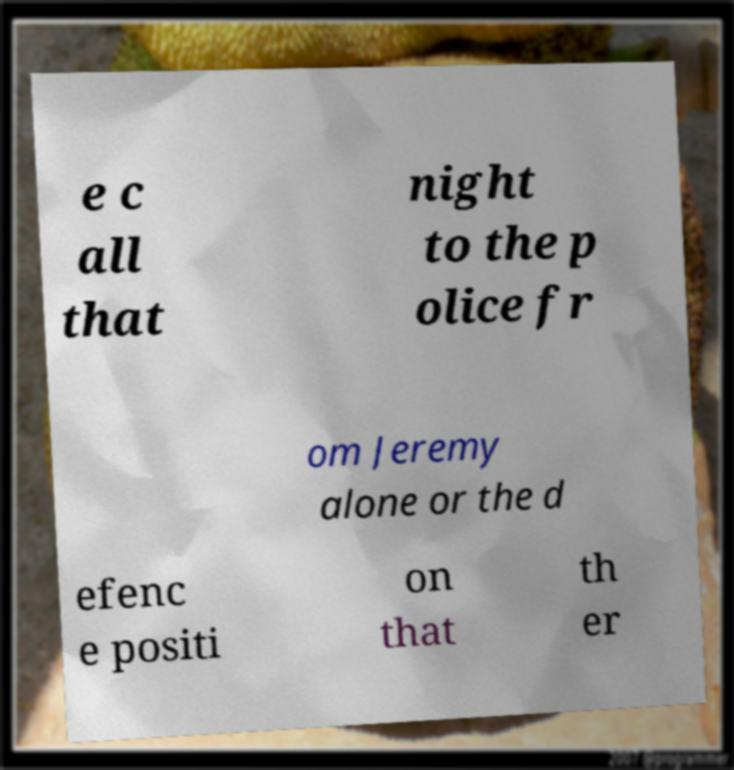Can you read and provide the text displayed in the image?This photo seems to have some interesting text. Can you extract and type it out for me? e c all that night to the p olice fr om Jeremy alone or the d efenc e positi on that th er 